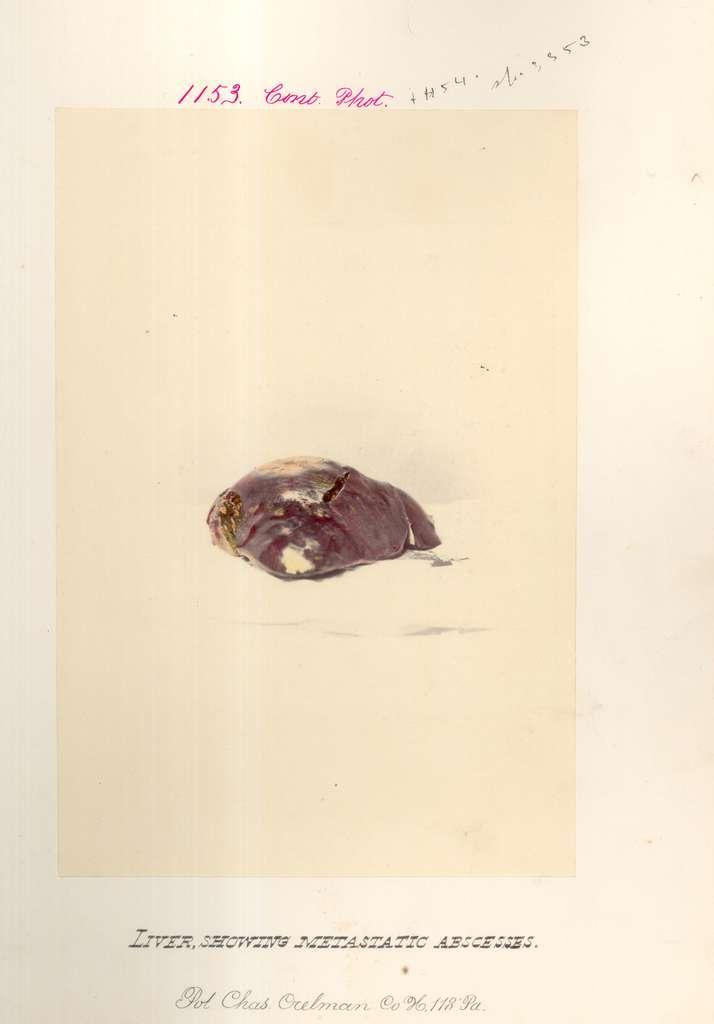What is the main object in the image? There is a card in the image. What is in the center of the card? There is a lac resin in the center of the card. What can be found at the top of the card? There is text written at the top of the card. What can be found at the bottom of the card? There is text written at the bottom of the card. Can you see a bee collecting nectar from the lac resin in the image? There is no bee present in the image, and the lac resin is not a source of nectar for bees. 